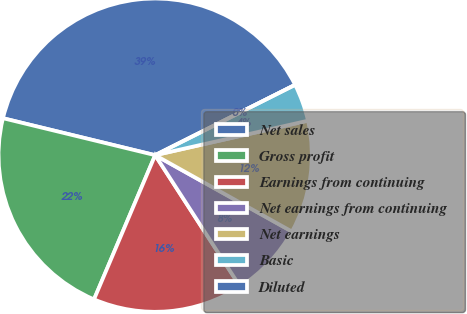Convert chart. <chart><loc_0><loc_0><loc_500><loc_500><pie_chart><fcel>Net sales<fcel>Gross profit<fcel>Earnings from continuing<fcel>Net earnings from continuing<fcel>Net earnings<fcel>Basic<fcel>Diluted<nl><fcel>38.8%<fcel>22.41%<fcel>15.52%<fcel>7.76%<fcel>11.64%<fcel>3.88%<fcel>0.0%<nl></chart> 